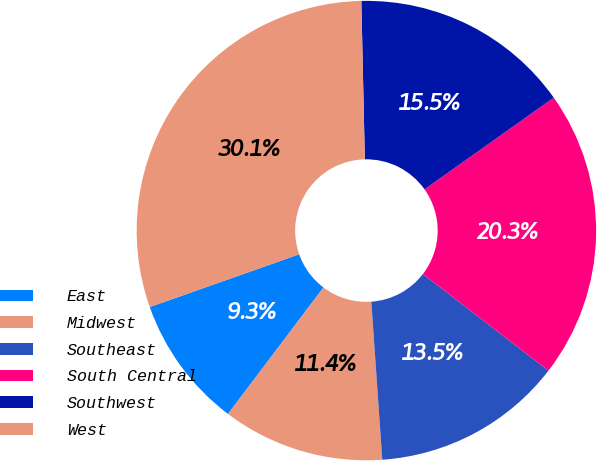Convert chart to OTSL. <chart><loc_0><loc_0><loc_500><loc_500><pie_chart><fcel>East<fcel>Midwest<fcel>Southeast<fcel>South Central<fcel>Southwest<fcel>West<nl><fcel>9.31%<fcel>11.39%<fcel>13.46%<fcel>20.26%<fcel>15.53%<fcel>30.05%<nl></chart> 